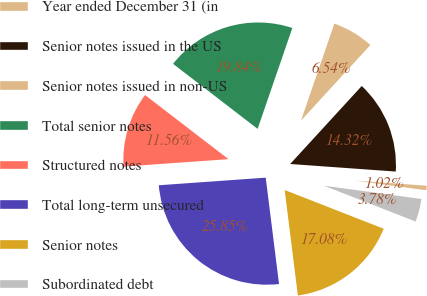<chart> <loc_0><loc_0><loc_500><loc_500><pie_chart><fcel>Year ended December 31 (in<fcel>Senior notes issued in the US<fcel>Senior notes issued in non-US<fcel>Total senior notes<fcel>Structured notes<fcel>Total long-term unsecured<fcel>Senior notes<fcel>Subordinated debt<nl><fcel>1.02%<fcel>14.32%<fcel>6.54%<fcel>19.84%<fcel>11.56%<fcel>25.85%<fcel>17.08%<fcel>3.78%<nl></chart> 